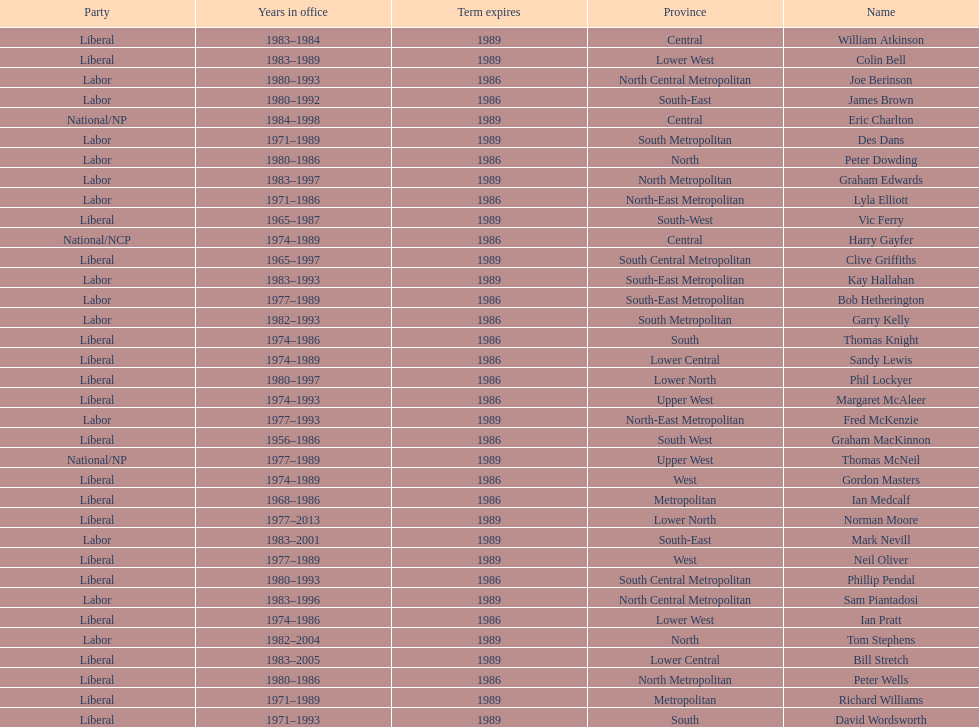What is the total number of members whose term expires in 1989? 9. Give me the full table as a dictionary. {'header': ['Party', 'Years in office', 'Term expires', 'Province', 'Name'], 'rows': [['Liberal', '1983–1984', '1989', 'Central', 'William Atkinson'], ['Liberal', '1983–1989', '1989', 'Lower West', 'Colin Bell'], ['Labor', '1980–1993', '1986', 'North Central Metropolitan', 'Joe Berinson'], ['Labor', '1980–1992', '1986', 'South-East', 'James Brown'], ['National/NP', '1984–1998', '1989', 'Central', 'Eric Charlton'], ['Labor', '1971–1989', '1989', 'South Metropolitan', 'Des Dans'], ['Labor', '1980–1986', '1986', 'North', 'Peter Dowding'], ['Labor', '1983–1997', '1989', 'North Metropolitan', 'Graham Edwards'], ['Labor', '1971–1986', '1986', 'North-East Metropolitan', 'Lyla Elliott'], ['Liberal', '1965–1987', '1989', 'South-West', 'Vic Ferry'], ['National/NCP', '1974–1989', '1986', 'Central', 'Harry Gayfer'], ['Liberal', '1965–1997', '1989', 'South Central Metropolitan', 'Clive Griffiths'], ['Labor', '1983–1993', '1989', 'South-East Metropolitan', 'Kay Hallahan'], ['Labor', '1977–1989', '1986', 'South-East Metropolitan', 'Bob Hetherington'], ['Labor', '1982–1993', '1986', 'South Metropolitan', 'Garry Kelly'], ['Liberal', '1974–1986', '1986', 'South', 'Thomas Knight'], ['Liberal', '1974–1989', '1986', 'Lower Central', 'Sandy Lewis'], ['Liberal', '1980–1997', '1986', 'Lower North', 'Phil Lockyer'], ['Liberal', '1974–1993', '1986', 'Upper West', 'Margaret McAleer'], ['Labor', '1977–1993', '1989', 'North-East Metropolitan', 'Fred McKenzie'], ['Liberal', '1956–1986', '1986', 'South West', 'Graham MacKinnon'], ['National/NP', '1977–1989', '1989', 'Upper West', 'Thomas McNeil'], ['Liberal', '1974–1989', '1986', 'West', 'Gordon Masters'], ['Liberal', '1968–1986', '1986', 'Metropolitan', 'Ian Medcalf'], ['Liberal', '1977–2013', '1989', 'Lower North', 'Norman Moore'], ['Labor', '1983–2001', '1989', 'South-East', 'Mark Nevill'], ['Liberal', '1977–1989', '1989', 'West', 'Neil Oliver'], ['Liberal', '1980–1993', '1986', 'South Central Metropolitan', 'Phillip Pendal'], ['Labor', '1983–1996', '1989', 'North Central Metropolitan', 'Sam Piantadosi'], ['Liberal', '1974–1986', '1986', 'Lower West', 'Ian Pratt'], ['Labor', '1982–2004', '1989', 'North', 'Tom Stephens'], ['Liberal', '1983–2005', '1989', 'Lower Central', 'Bill Stretch'], ['Liberal', '1980–1986', '1986', 'North Metropolitan', 'Peter Wells'], ['Liberal', '1971–1989', '1989', 'Metropolitan', 'Richard Williams'], ['Liberal', '1971–1993', '1989', 'South', 'David Wordsworth']]} 